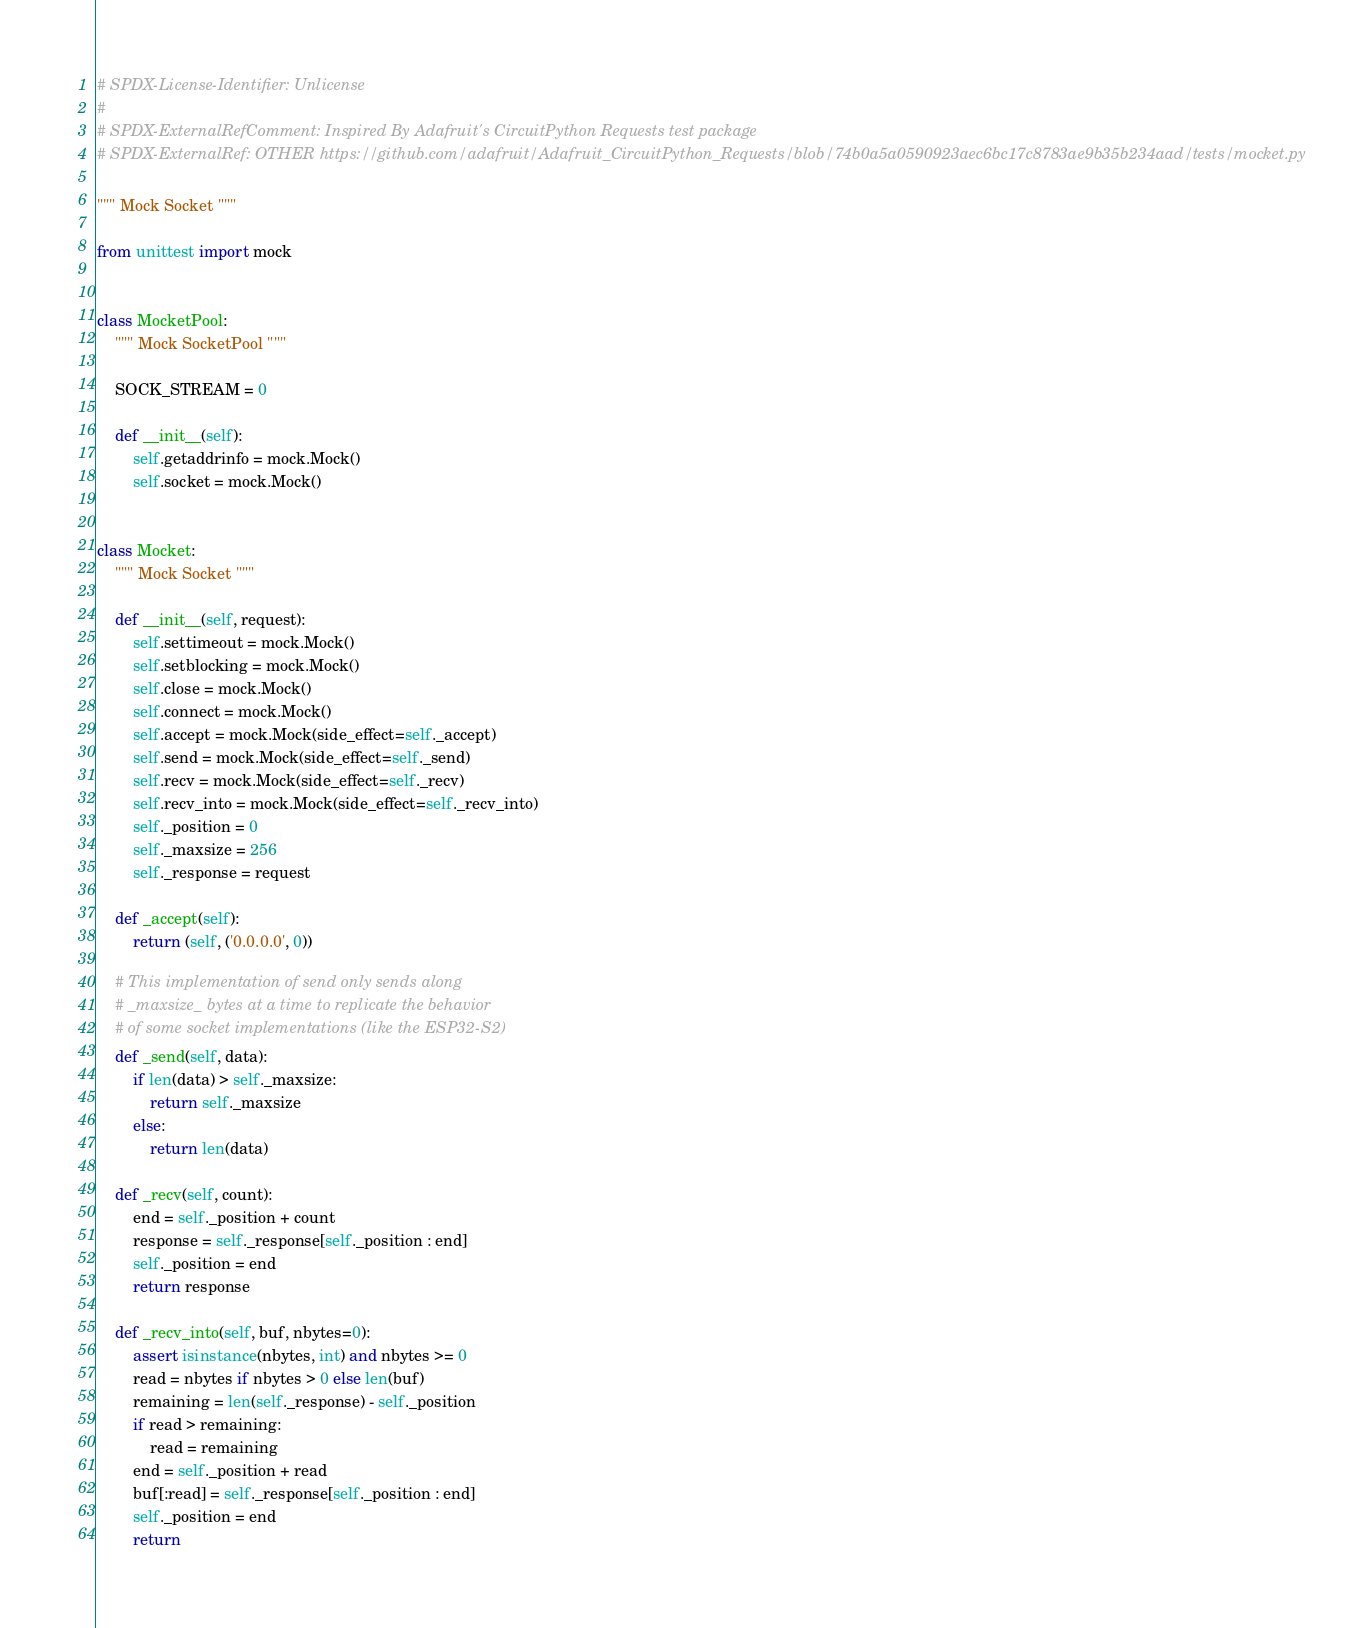<code> <loc_0><loc_0><loc_500><loc_500><_Python_># SPDX-License-Identifier: Unlicense
#
# SPDX-ExternalRefComment: Inspired By Adafruit's CircuitPython Requests test package
# SPDX-ExternalRef: OTHER https://github.com/adafruit/Adafruit_CircuitPython_Requests/blob/74b0a5a0590923aec6bc17c8783ae9b35b234aad/tests/mocket.py

""" Mock Socket """

from unittest import mock


class MocketPool:
    """ Mock SocketPool """

    SOCK_STREAM = 0

    def __init__(self):
        self.getaddrinfo = mock.Mock()
        self.socket = mock.Mock()


class Mocket:
    """ Mock Socket """

    def __init__(self, request):
        self.settimeout = mock.Mock()
        self.setblocking = mock.Mock()
        self.close = mock.Mock()
        self.connect = mock.Mock()
        self.accept = mock.Mock(side_effect=self._accept)
        self.send = mock.Mock(side_effect=self._send)
        self.recv = mock.Mock(side_effect=self._recv)
        self.recv_into = mock.Mock(side_effect=self._recv_into)
        self._position = 0
        self._maxsize = 256
        self._response = request

    def _accept(self):
        return (self, ('0.0.0.0', 0))

    # This implementation of send only sends along
    # _maxsize_ bytes at a time to replicate the behavior
    # of some socket implementations (like the ESP32-S2)
    def _send(self, data):
        if len(data) > self._maxsize:
            return self._maxsize
        else:
            return len(data)

    def _recv(self, count):
        end = self._position + count
        response = self._response[self._position : end]
        self._position = end
        return response

    def _recv_into(self, buf, nbytes=0):
        assert isinstance(nbytes, int) and nbytes >= 0
        read = nbytes if nbytes > 0 else len(buf)
        remaining = len(self._response) - self._position
        if read > remaining:
            read = remaining
        end = self._position + read
        buf[:read] = self._response[self._position : end]
        self._position = end
        return
</code> 